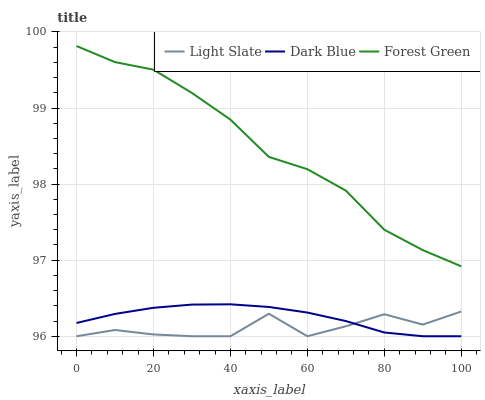Does Light Slate have the minimum area under the curve?
Answer yes or no. Yes. Does Forest Green have the maximum area under the curve?
Answer yes or no. Yes. Does Dark Blue have the minimum area under the curve?
Answer yes or no. No. Does Dark Blue have the maximum area under the curve?
Answer yes or no. No. Is Dark Blue the smoothest?
Answer yes or no. Yes. Is Light Slate the roughest?
Answer yes or no. Yes. Is Forest Green the smoothest?
Answer yes or no. No. Is Forest Green the roughest?
Answer yes or no. No. Does Light Slate have the lowest value?
Answer yes or no. Yes. Does Forest Green have the lowest value?
Answer yes or no. No. Does Forest Green have the highest value?
Answer yes or no. Yes. Does Dark Blue have the highest value?
Answer yes or no. No. Is Dark Blue less than Forest Green?
Answer yes or no. Yes. Is Forest Green greater than Dark Blue?
Answer yes or no. Yes. Does Dark Blue intersect Light Slate?
Answer yes or no. Yes. Is Dark Blue less than Light Slate?
Answer yes or no. No. Is Dark Blue greater than Light Slate?
Answer yes or no. No. Does Dark Blue intersect Forest Green?
Answer yes or no. No. 